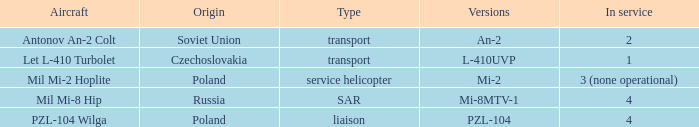Tell me the versions for czechoslovakia? L-410UVP. 